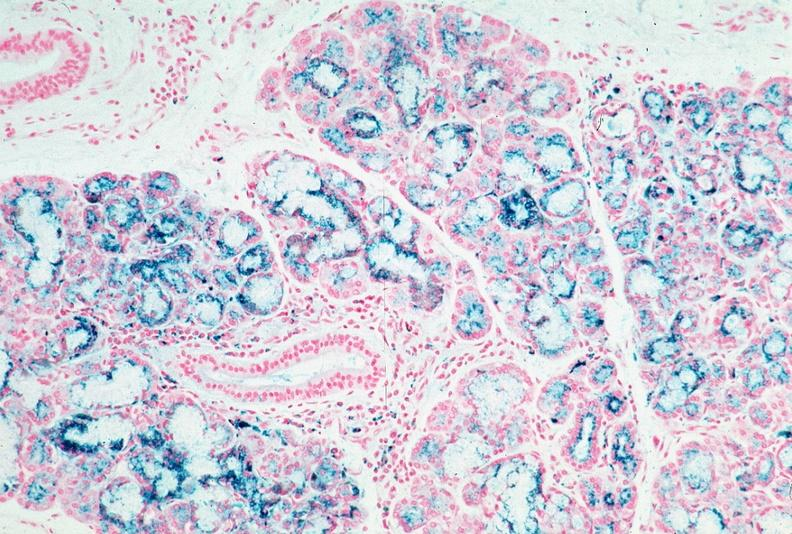what does this image show?
Answer the question using a single word or phrase. Pancreas 